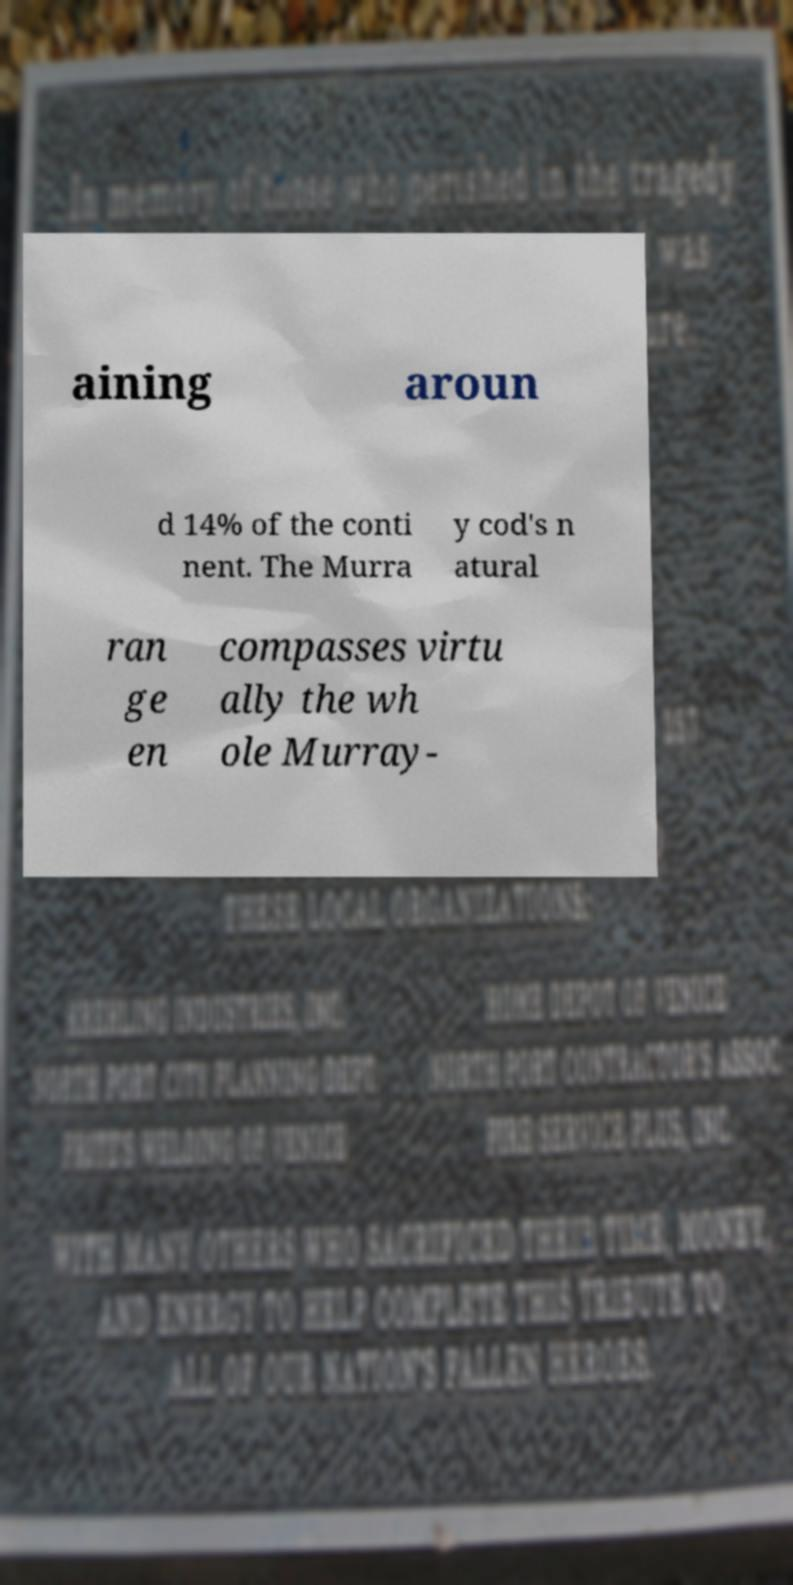For documentation purposes, I need the text within this image transcribed. Could you provide that? aining aroun d 14% of the conti nent. The Murra y cod's n atural ran ge en compasses virtu ally the wh ole Murray- 